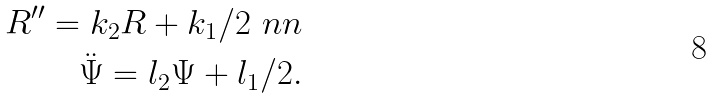Convert formula to latex. <formula><loc_0><loc_0><loc_500><loc_500>R ^ { \prime \prime } = k _ { 2 } R + k _ { 1 } / 2 \ n n \\ \ddot { \Psi } = l _ { 2 } \Psi + l _ { 1 } / 2 .</formula> 